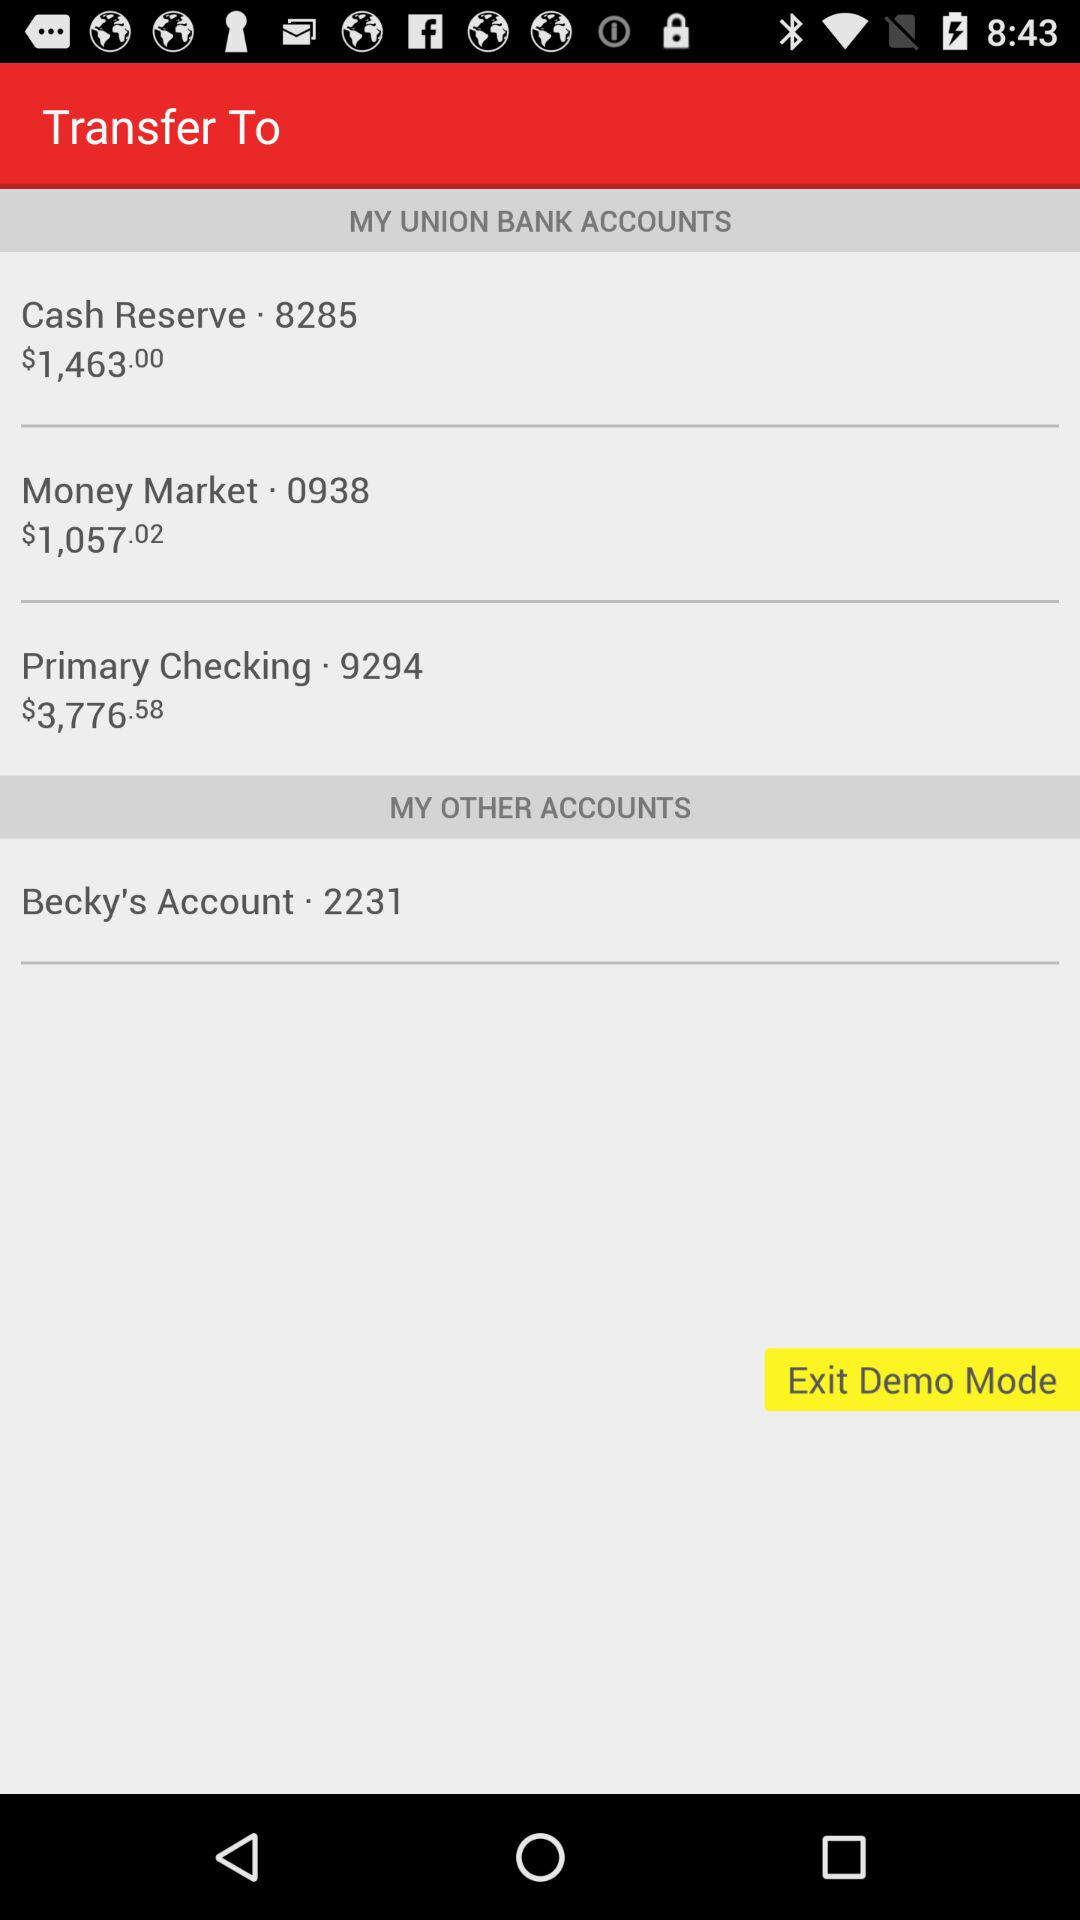How much more money is in the Primary Checking account than the Money Market account?
Answer the question using a single word or phrase. $2,719.56 